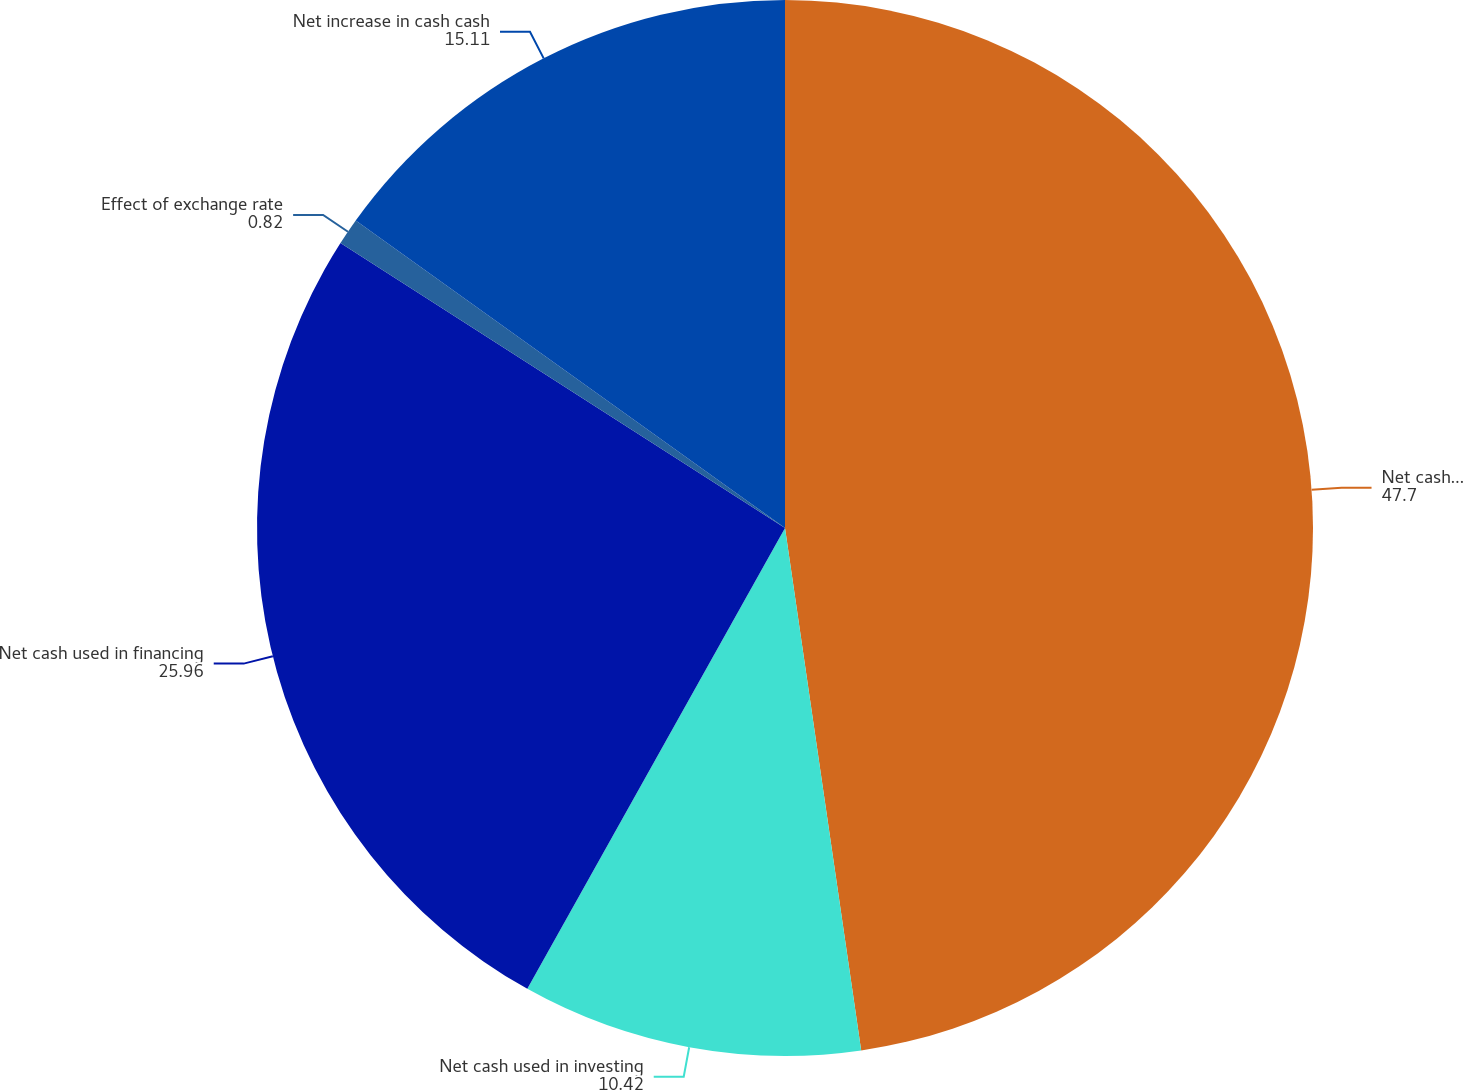<chart> <loc_0><loc_0><loc_500><loc_500><pie_chart><fcel>Net cash provided by operating<fcel>Net cash used in investing<fcel>Net cash used in financing<fcel>Effect of exchange rate<fcel>Net increase in cash cash<nl><fcel>47.7%<fcel>10.42%<fcel>25.96%<fcel>0.82%<fcel>15.11%<nl></chart> 